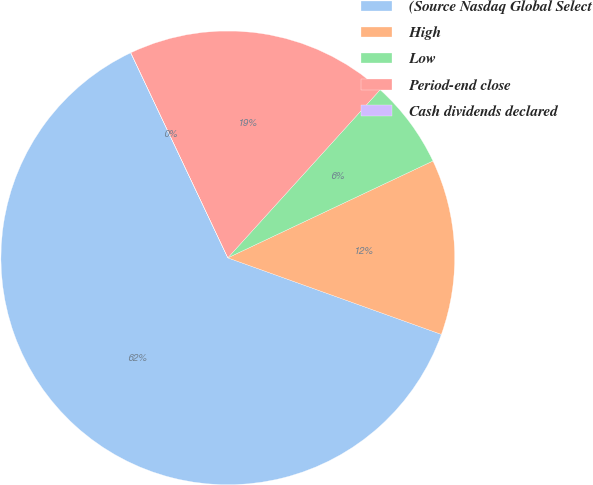<chart> <loc_0><loc_0><loc_500><loc_500><pie_chart><fcel>(Source Nasdaq Global Select<fcel>High<fcel>Low<fcel>Period-end close<fcel>Cash dividends declared<nl><fcel>62.48%<fcel>12.5%<fcel>6.26%<fcel>18.75%<fcel>0.01%<nl></chart> 